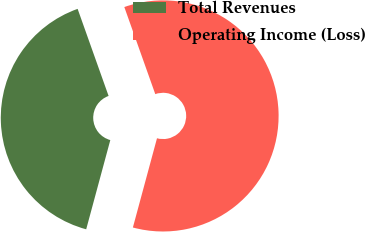<chart> <loc_0><loc_0><loc_500><loc_500><pie_chart><fcel>Total Revenues<fcel>Operating Income (Loss)<nl><fcel>40.36%<fcel>59.64%<nl></chart> 